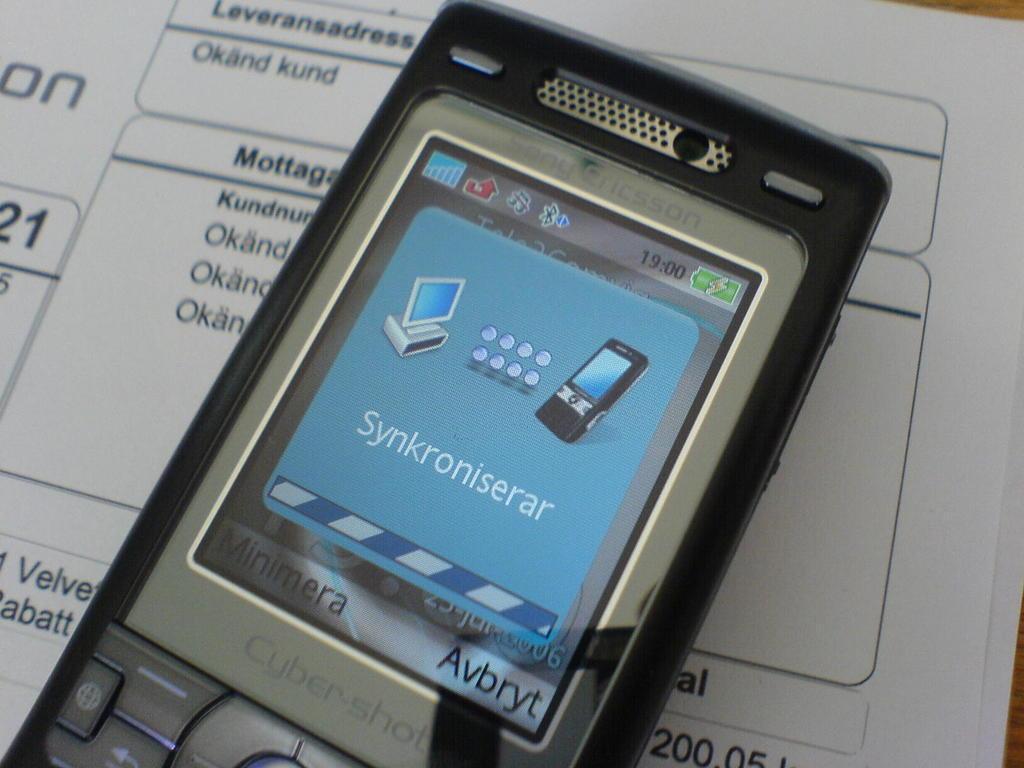In one or two sentences, can you explain what this image depicts? In this image there is a table with a few papers and text on it and in the middle of the image there is a mobile phone on the papers. 